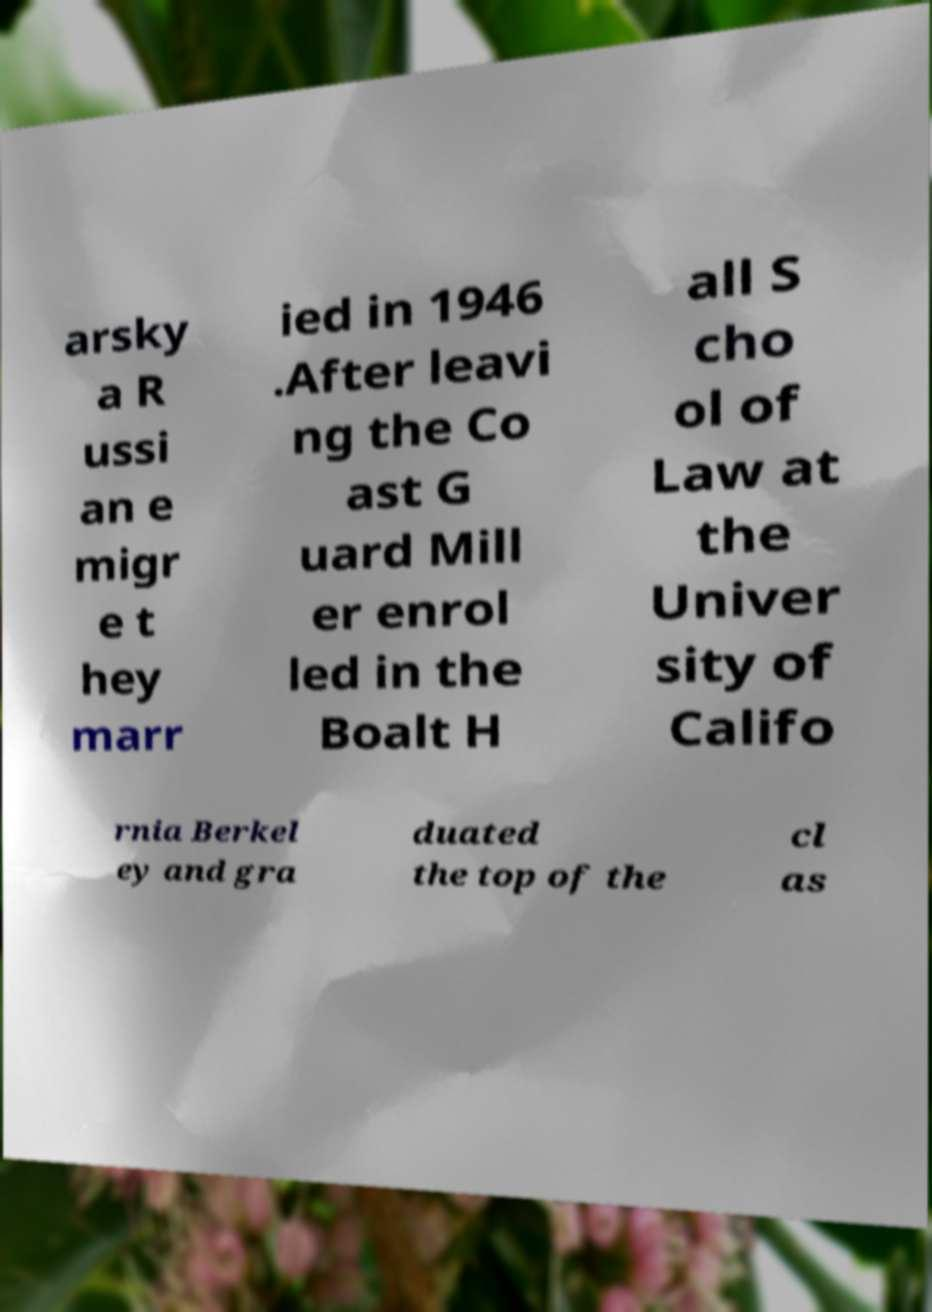What messages or text are displayed in this image? I need them in a readable, typed format. arsky a R ussi an e migr e t hey marr ied in 1946 .After leavi ng the Co ast G uard Mill er enrol led in the Boalt H all S cho ol of Law at the Univer sity of Califo rnia Berkel ey and gra duated the top of the cl as 